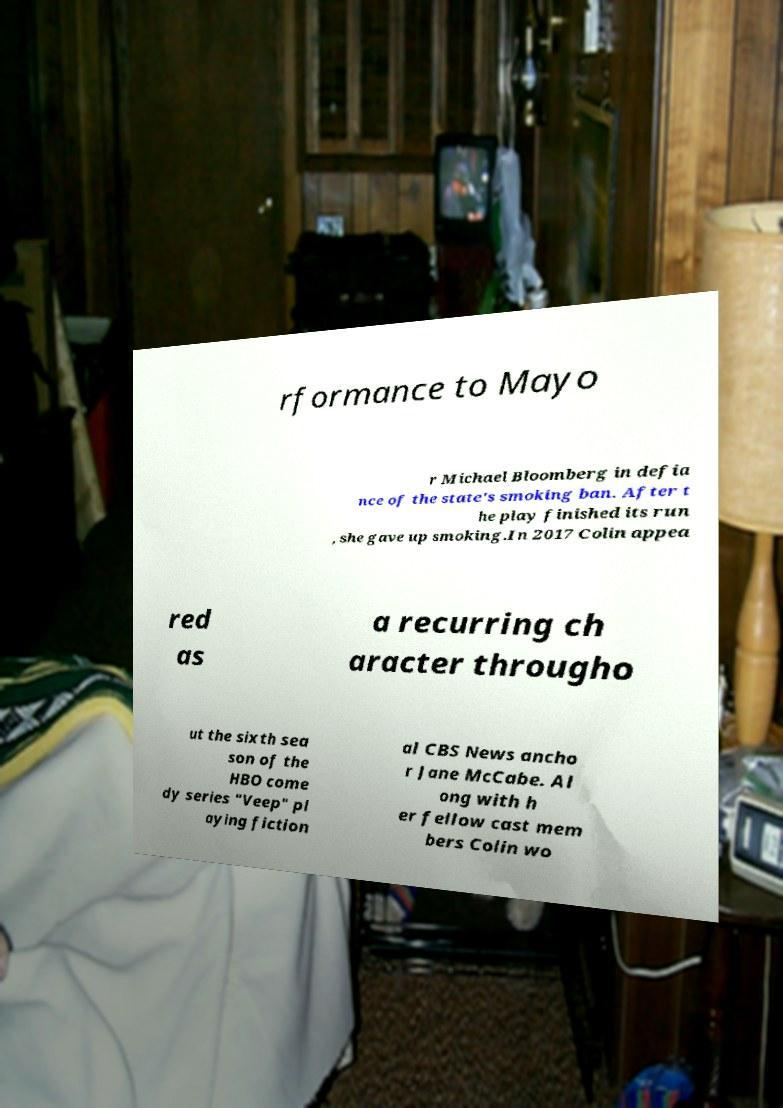There's text embedded in this image that I need extracted. Can you transcribe it verbatim? rformance to Mayo r Michael Bloomberg in defia nce of the state's smoking ban. After t he play finished its run , she gave up smoking.In 2017 Colin appea red as a recurring ch aracter througho ut the sixth sea son of the HBO come dy series "Veep" pl aying fiction al CBS News ancho r Jane McCabe. Al ong with h er fellow cast mem bers Colin wo 